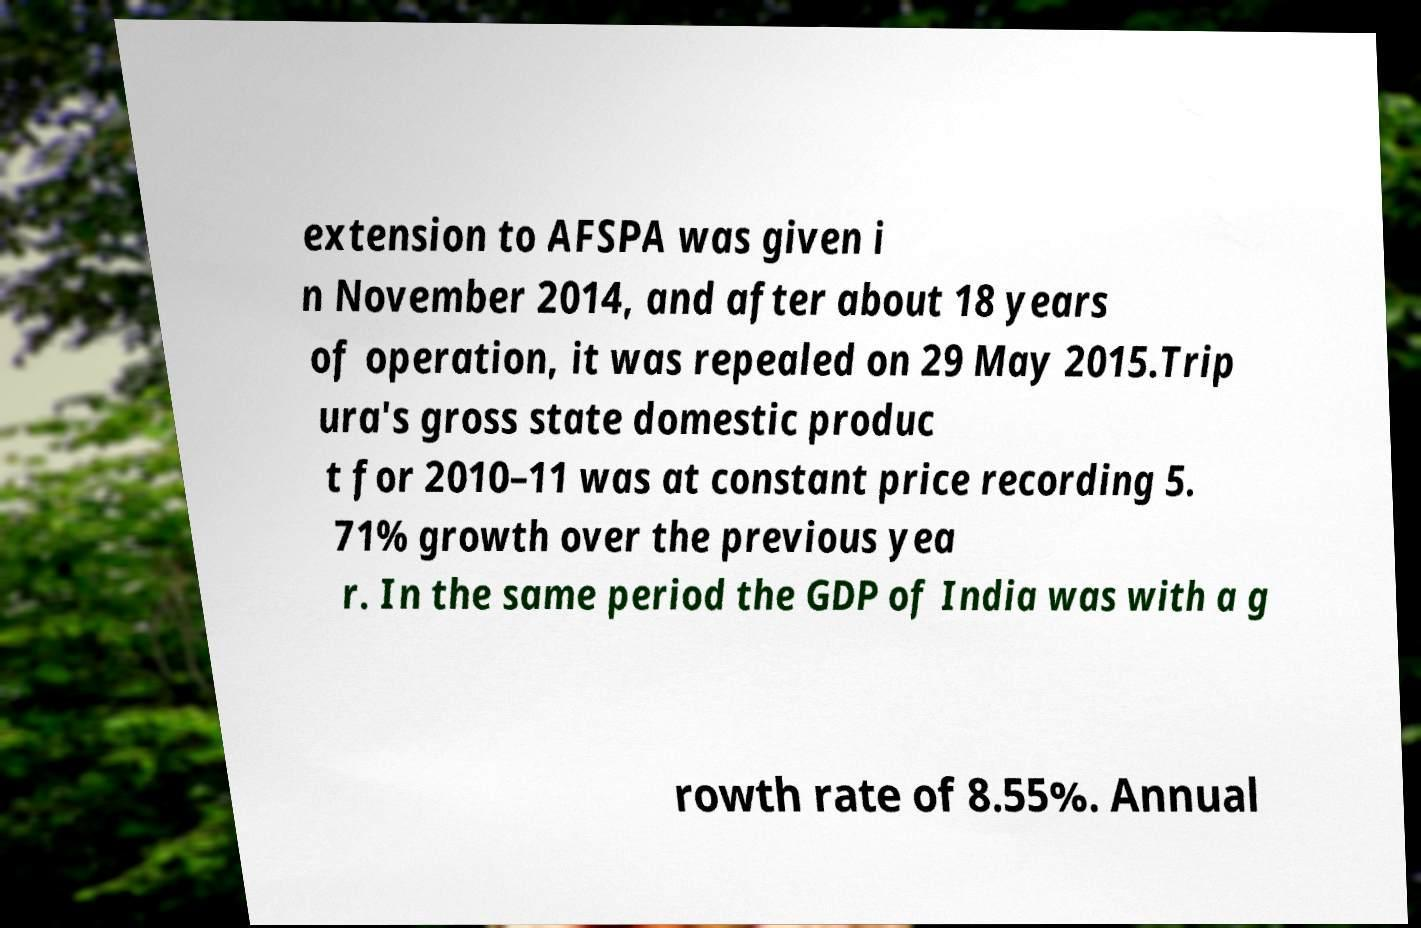Could you extract and type out the text from this image? extension to AFSPA was given i n November 2014, and after about 18 years of operation, it was repealed on 29 May 2015.Trip ura's gross state domestic produc t for 2010–11 was at constant price recording 5. 71% growth over the previous yea r. In the same period the GDP of India was with a g rowth rate of 8.55%. Annual 